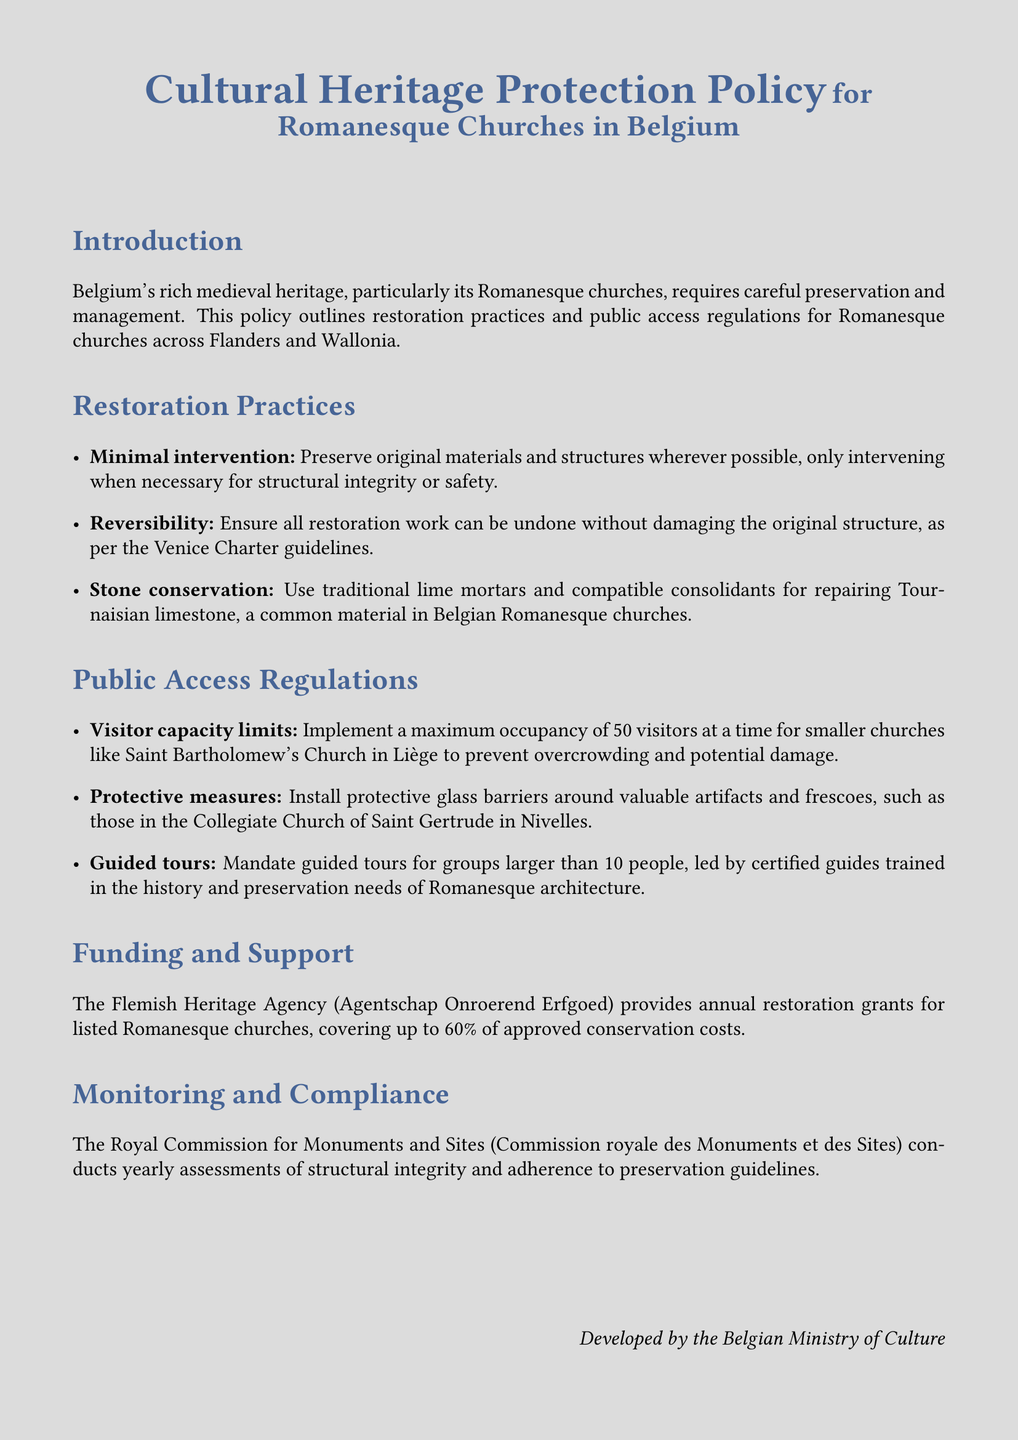What is the title of the document? The title is prominently displayed at the top of the document for easy identification.
Answer: Cultural Heritage Protection Policy for Romanesque Churches in Belgium What is the maximum occupancy for smaller churches? The policy specifies visitor capacity limits to ensure preservation and safety in the churches.
Answer: 50 What does the policy emphasize regarding intervention in restoration? The document outlines specific principles for restoration practices, including minimal intervention.
Answer: Minimal intervention What type of barriers are recommended around valuable artifacts? The document mentions protective measures to safeguard heritage features within the churches.
Answer: Protective glass barriers Which agency provides restoration grants? The funding section includes the name of the agency responsible for financial support in preservation.
Answer: Flemish Heritage Agency What is the percentage of conservation costs covered by grants? The document specifies the financial support ratio available for restoration projects.
Answer: 60% Who conducts yearly assessments of structural integrity? The policy describes the oversight body responsible for monitoring and compliance with restoration practices.
Answer: Royal Commission for Monuments and Sites What should guided tours be led by? The document mandates certain qualifications for individuals leading tours in Romanesque churches.
Answer: Certified guides What is a key material mentioned for stone conservation? The restoration practices section identifies specific materials used in the conservation of churches.
Answer: Tournaisian limestone 